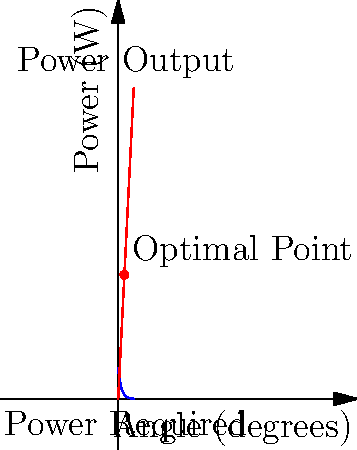As an e-bike store owner, you're testing a new model to determine its optimal performance. The graph shows the power output of the e-bike (blue curve) and the power required to climb an incline (red line) as functions of the incline angle. Given that the power output function is $P(x) = 100e^{-0.1x}$ watts and the power required function is $R(x) = 20x$ watts, where $x$ is the angle in degrees, find the optimal angle of incline that maximizes the e-bike's range. To find the optimal angle, we need to determine where the power output equals the power required:

1) Set up the equation: $100e^{-0.1x} = 20x$

2) This equation can't be solved algebraically, so we'll use a graphical method.

3) The intersection point of the two curves represents the optimal angle.

4) From the graph, we can see that the curves intersect at approximately 20 degrees.

5) To verify, we can calculate:
   At $x = 20$:
   $P(20) = 100e^{-0.1(20)} \approx 368.8$ W
   $R(20) = 20(20) = 400$ W

6) These values are close, confirming that 20 degrees is near the optimal angle.

7) At this angle, the e-bike is using all its available power to climb, maximizing its range for the given incline.

8) For angles greater than 20°, the power required exceeds the power output, potentially causing the e-bike to slow down or stop.

9) For angles less than 20°, the e-bike has excess power, but it's not utilizing its full capability to climb and extend its range.
Answer: Approximately 20 degrees 